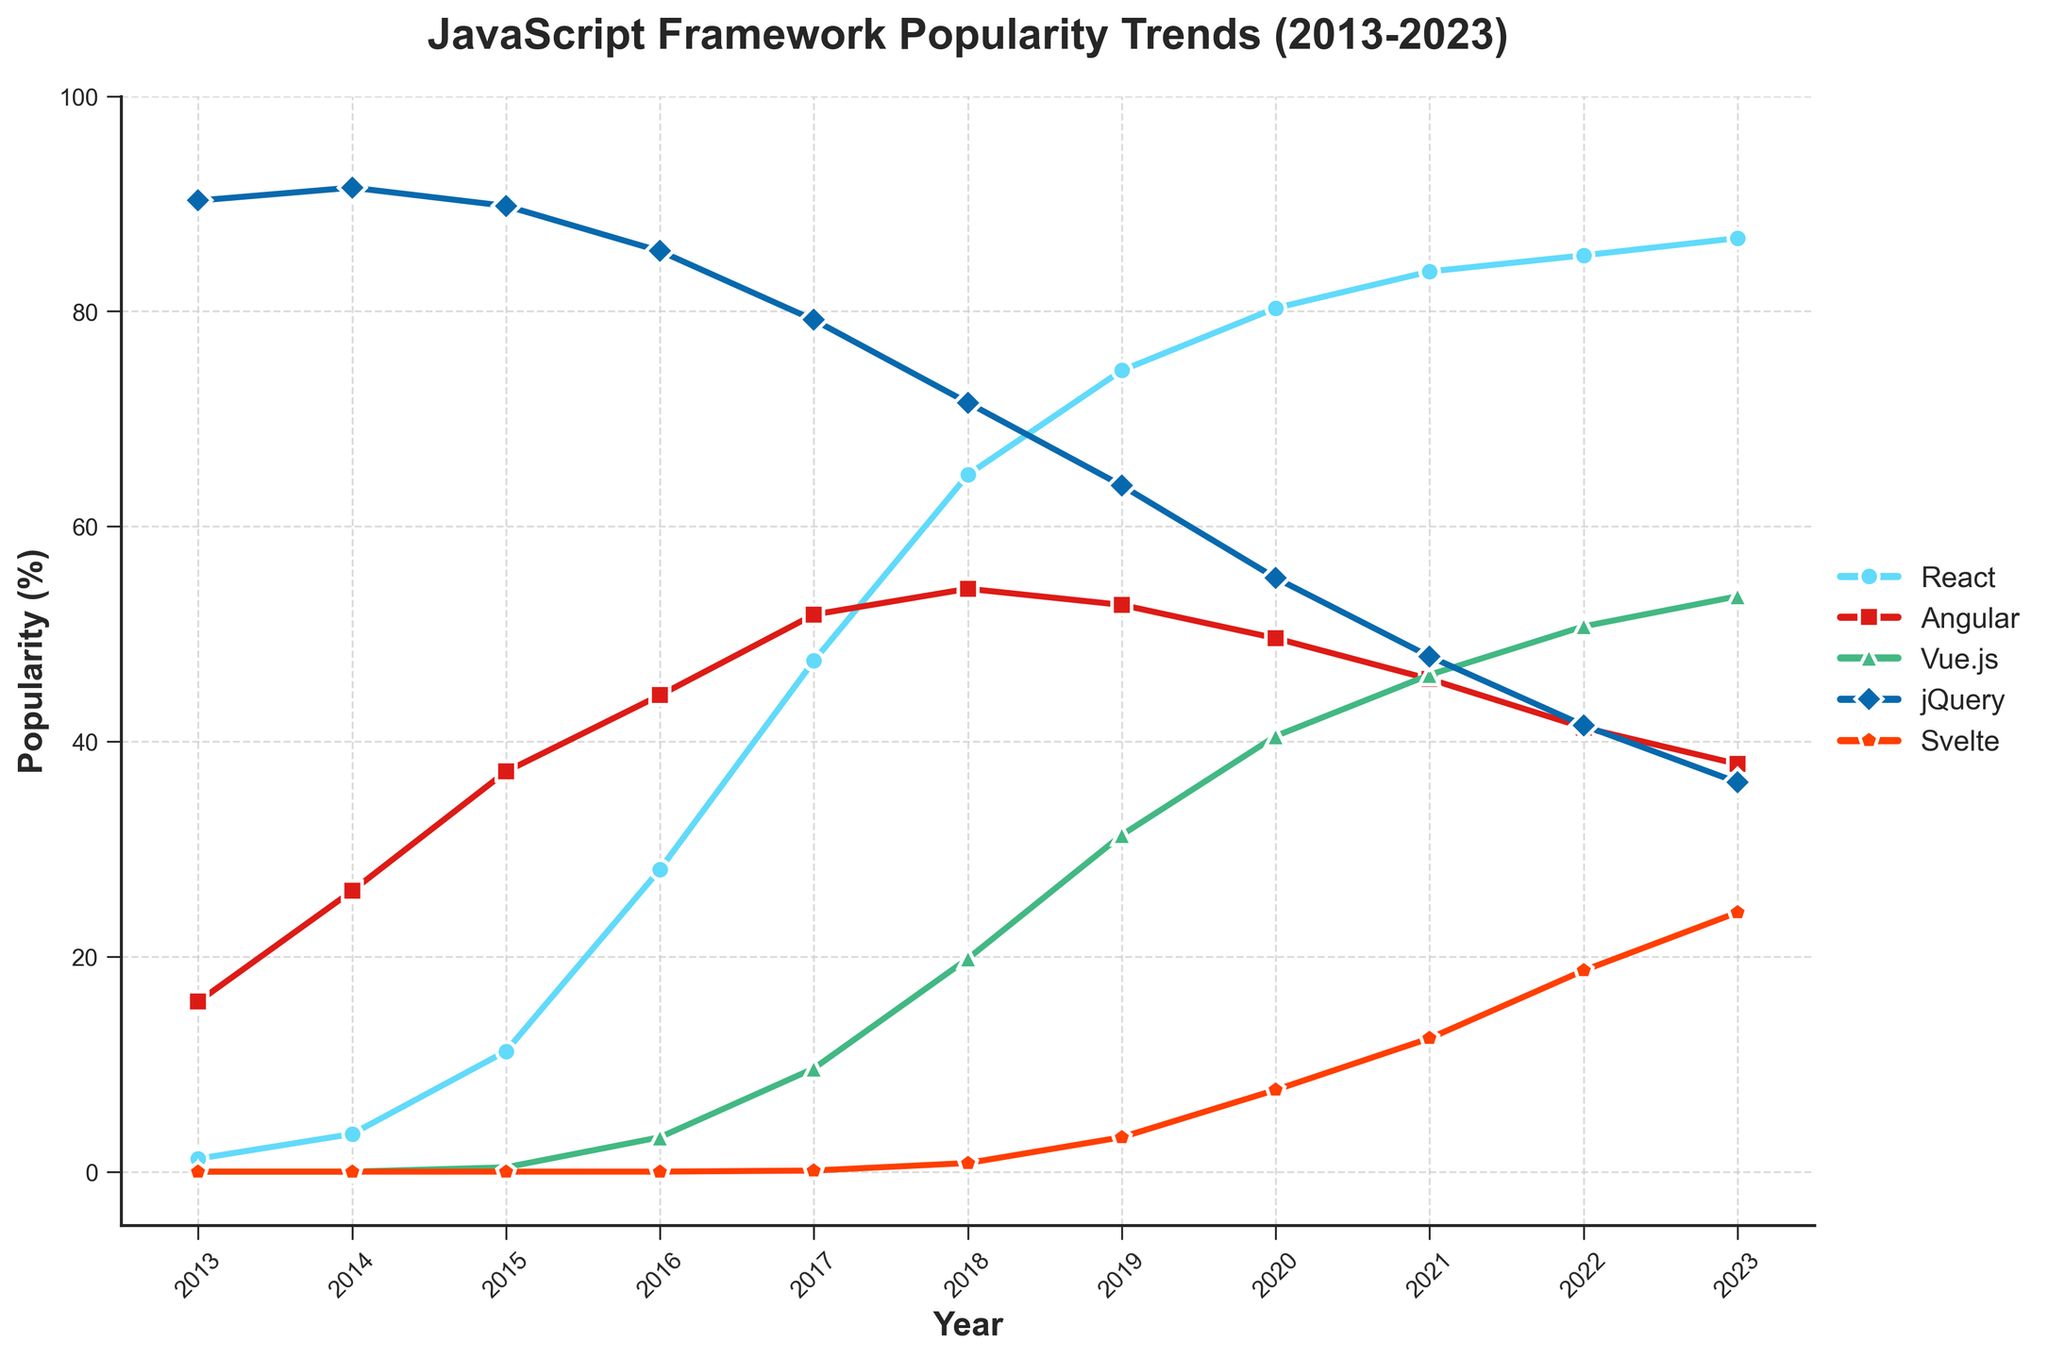What is the trend of React's popularity between 2013 and 2023? To determine React's trend, observe the line corresponding to React in the chart from 2013 to 2023. The upward slope signifies an increase in popularity over the years.
Answer: Increasing Which framework had the highest popularity in 2023? Check the points on the line chart for each framework in the year 2023. React's point is the highest, indicating it had the highest popularity.
Answer: React Which two frameworks experienced a decline in popularity between 2018 and 2023? Observe the slope of the lines from 2018 to 2023. Both Angular and jQuery show a downward slope in this period, indicating a decline in popularity.
Answer: Angular and jQuery What is the difference in Vue.js's popularity between 2016 and 2020? Note Vue.js's popularity percentages in 2016 (3.2) and 2020 (40.5). Subtract the earlier value from the later one: 40.5 - 3.2.
Answer: 37.3 Which framework showed the most significant growth in popularity from 2015 to 2017? Compare the slopes of the lines for each framework between 2015 and 2017. React's line has the steepest upward slope, indicating the most significant growth in popularity.
Answer: React What is the aggregate popularity of React, Vue.js, and Svelte in 2023? Check the popularity percentages for React (86.8), Vue.js (53.5), and Svelte (24.1) in 2023. Add these values together: 86.8 + 53.5 + 24.1.
Answer: 164.4 Between which two consecutive years did jQuery see the most significant drop in popularity? Observe the drop in jQuery's popularity between each pair of consecutive years on the line chart. The biggest drop is between 2017 (79.2) and 2018 (71.5), where it decreases by 7.7.
Answer: 2017 and 2018 Which framework had the slowest growth over the decade? Compare the total growth for each framework from 2013 to 2023. Angular grows from 15.8 to 37.9, which is a relatively smaller increase compared to others.
Answer: Angular What is the average annual popularity of Svelte between 2019 and 2023? Add Svelte's popularity percentages for each year from 2019 to 2023 (3.2, 7.6, 12.4, 18.7, 24.1), and then divide by the number of years (5): (3.2 + 7.6 + 12.4 + 18.7 + 24.1)/5.
Answer: 13.2 Which framework had the most fluctuating trend line from 2013 to 2023? Look at the changes in the slopes for each framework. jQuery's line has visible peaks and troughs, indicating the most fluctuations.
Answer: jQuery 